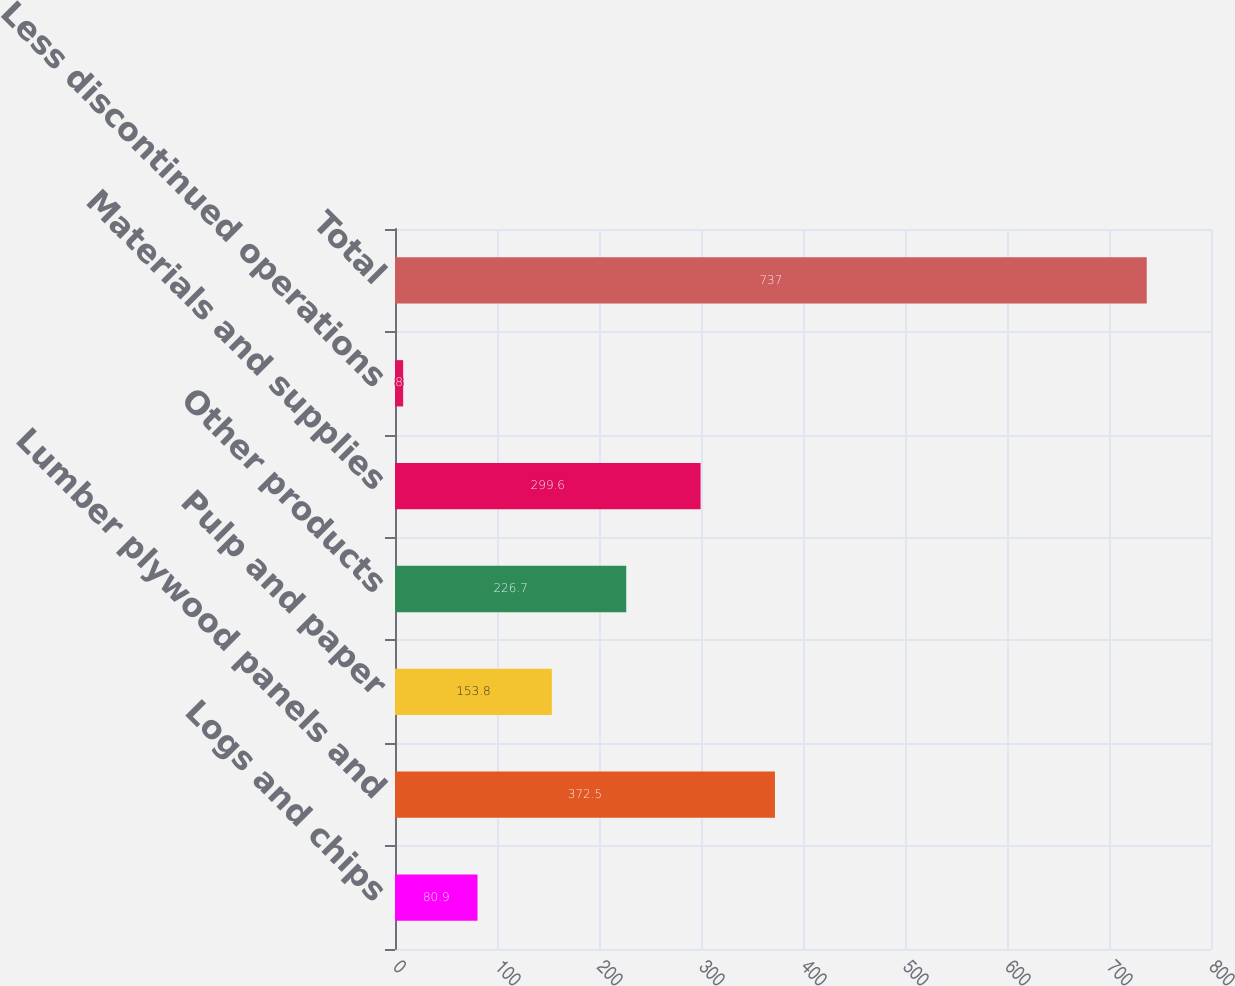Convert chart. <chart><loc_0><loc_0><loc_500><loc_500><bar_chart><fcel>Logs and chips<fcel>Lumber plywood panels and<fcel>Pulp and paper<fcel>Other products<fcel>Materials and supplies<fcel>Less discontinued operations<fcel>Total<nl><fcel>80.9<fcel>372.5<fcel>153.8<fcel>226.7<fcel>299.6<fcel>8<fcel>737<nl></chart> 